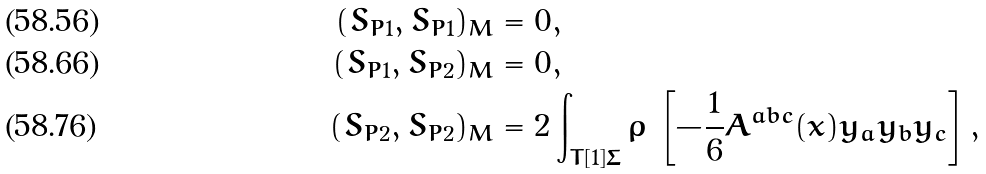<formula> <loc_0><loc_0><loc_500><loc_500>( S _ { P 1 } , S _ { P 1 } ) _ { M } & = 0 , \\ ( S _ { P 1 } , S _ { P 2 } ) _ { M } & = 0 , \\ ( S _ { P 2 } , S _ { P 2 } ) _ { M } & = 2 \int _ { T [ 1 ] \Sigma } \varrho \, \left [ - \frac { 1 } { 6 } A ^ { a b c } ( x ) y _ { a } y _ { b } y _ { c } \right ] ,</formula> 